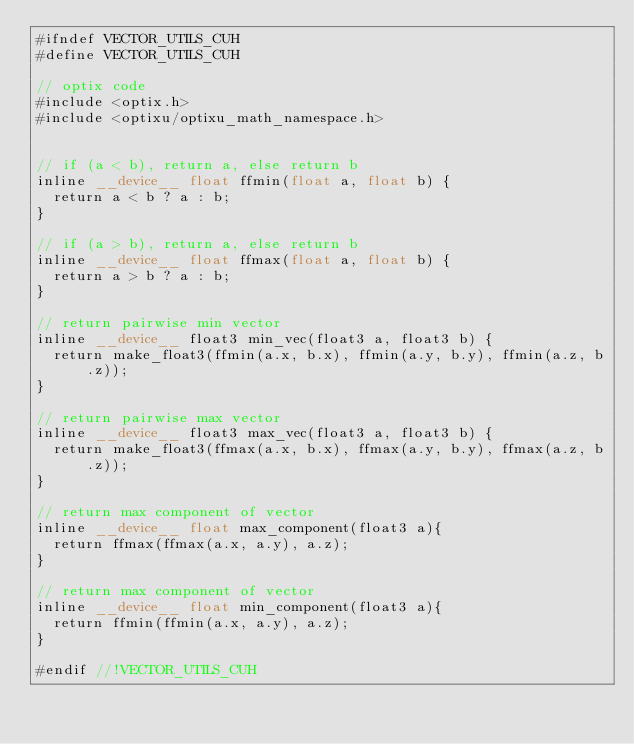Convert code to text. <code><loc_0><loc_0><loc_500><loc_500><_Cuda_>#ifndef VECTOR_UTILS_CUH
#define VECTOR_UTILS_CUH

// optix code
#include <optix.h>
#include <optixu/optixu_math_namespace.h>


// if (a < b), return a, else return b
inline __device__ float ffmin(float a, float b) {
	return a < b ? a : b;
}

// if (a > b), return a, else return b
inline __device__ float ffmax(float a, float b) {
	return a > b ? a : b;
}

// return pairwise min vector
inline __device__ float3 min_vec(float3 a, float3 b) {
	return make_float3(ffmin(a.x, b.x), ffmin(a.y, b.y), ffmin(a.z, b.z));
}

// return pairwise max vector
inline __device__ float3 max_vec(float3 a, float3 b) {
	return make_float3(ffmax(a.x, b.x), ffmax(a.y, b.y), ffmax(a.z, b.z));
}

// return max component of vector
inline __device__ float max_component(float3 a){
	return ffmax(ffmax(a.x, a.y), a.z);
}

// return max component of vector
inline __device__ float min_component(float3 a){
	return ffmin(ffmin(a.x, a.y), a.z);
}

#endif //!VECTOR_UTILS_CUH
</code> 